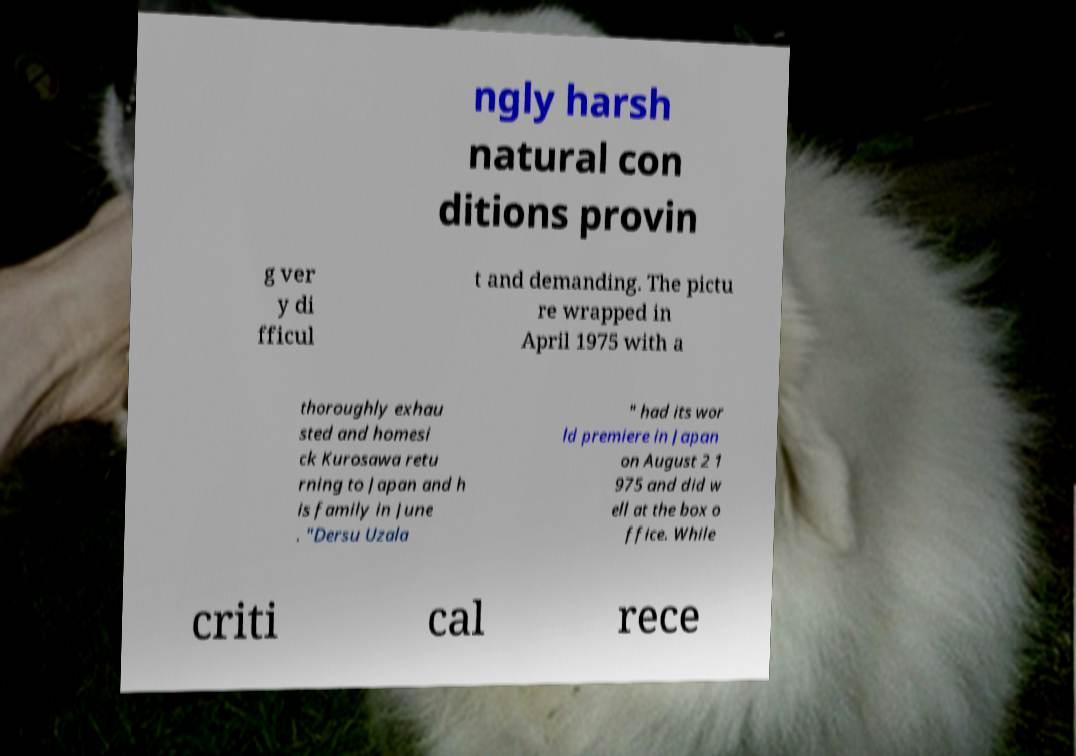Could you extract and type out the text from this image? ngly harsh natural con ditions provin g ver y di fficul t and demanding. The pictu re wrapped in April 1975 with a thoroughly exhau sted and homesi ck Kurosawa retu rning to Japan and h is family in June . "Dersu Uzala " had its wor ld premiere in Japan on August 2 1 975 and did w ell at the box o ffice. While criti cal rece 